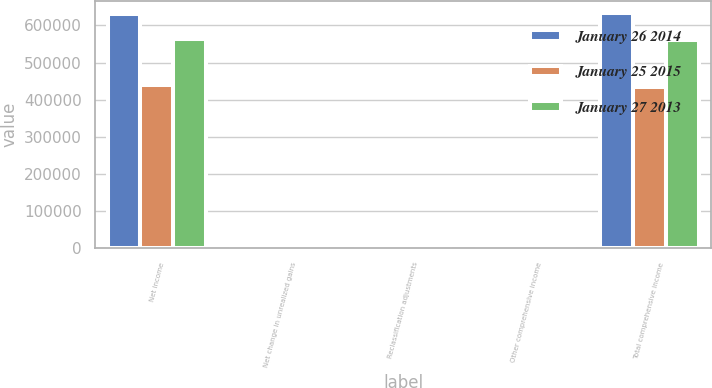Convert chart. <chart><loc_0><loc_0><loc_500><loc_500><stacked_bar_chart><ecel><fcel>Net income<fcel>Net change in unrealized gains<fcel>Reclassification adjustments<fcel>Other comprehensive income<fcel>Total comprehensive income<nl><fcel>January 26 2014<fcel>630587<fcel>3061<fcel>94<fcel>2967<fcel>633554<nl><fcel>January 25 2015<fcel>439990<fcel>3555<fcel>1549<fcel>5104<fcel>434886<nl><fcel>January 27 2013<fcel>562536<fcel>303<fcel>330<fcel>633<fcel>561903<nl></chart> 